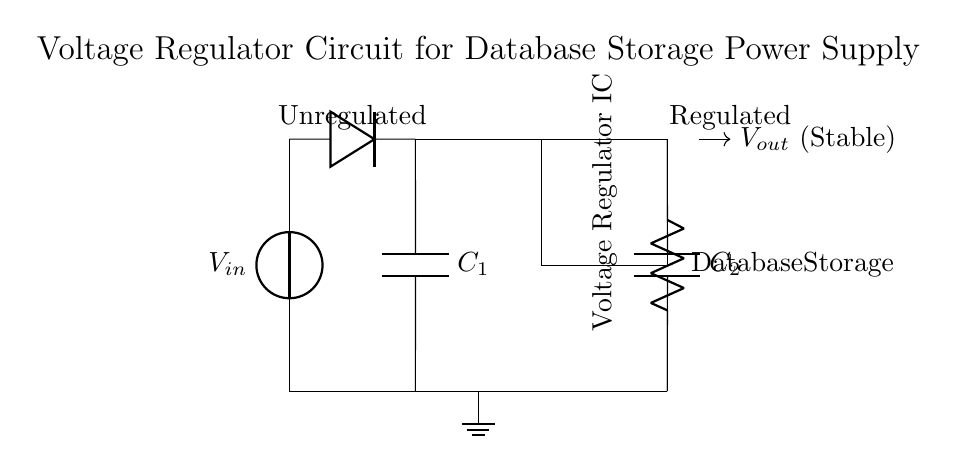What type of components are used in this circuit? The circuit includes a voltage source, diode, capacitor, voltage regulator IC, and resistor. These components are typical in a voltage regulation setup.
Answer: voltage source, diode, capacitor, voltage regulator IC, resistor What is the function of the smoothing capacitor in this circuit? The smoothing capacitor (C1) helps to filter and stabilize the output voltage after rectification, reducing voltage ripple and providing a more constant voltage.
Answer: Filter and stabilize voltage What does the label "Database Storage" represent in this circuit? The label "Database Storage" indicates the load that the voltage regulator supplies power to, simulating the storage devices that require stable voltage.
Answer: Load for stable power supply What is the purpose of the voltage regulator IC? The voltage regulator IC ensures that the output voltage remains stable despite variations in input voltage or load, critical for powering sensitive electronic devices.
Answer: Maintain stable output voltage How does the rectifier diode contribute to this circuit? The rectifier diode converts the AC input voltage from the power source to a pulsating DC voltage, which can then be smoothed by the capacitor and regulated.
Answer: Converts AC to DC How does the output capacitor affect the circuit operation? The output capacitor (C2) filters any remaining ripple and provides a low-impedance path for sudden load changes, thus enhancing the stability and response of the output voltage.
Answer: Reduces ripple and stabilizes output 